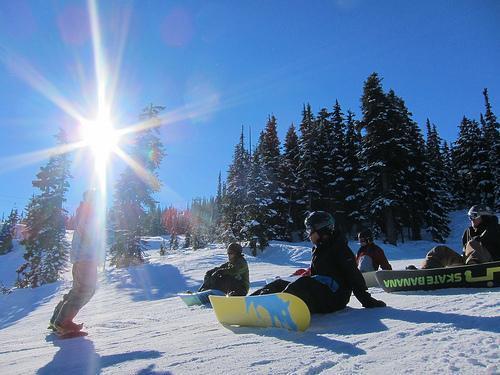How many dinosaurs are in the picture?
Give a very brief answer. 0. How many clouds are in the sky?
Give a very brief answer. 0. 